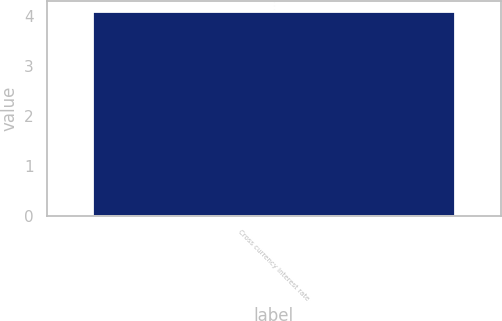Convert chart to OTSL. <chart><loc_0><loc_0><loc_500><loc_500><bar_chart><fcel>Cross currency interest rate<nl><fcel>4.1<nl></chart> 